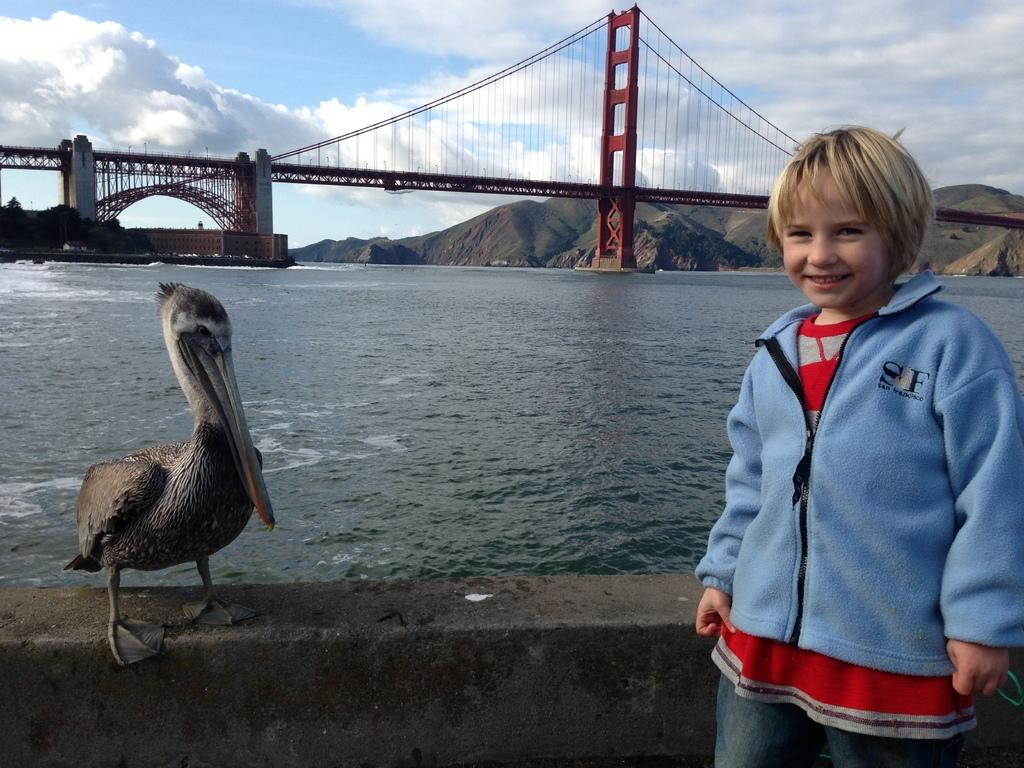What type of structure can be seen in the image? There is a bridge in the image. What is visible beneath the bridge? Water is visible in the image. What type of vegetation is present in the image? There are trees in the image. What is the child in the image doing? The child is standing in the image. Where is the bird located in the image? The bird is on a wall in the image. What can be seen in the background of the image? The sky, clouds, and mountains are visible in the background of the image. What color is the airport in the image? There is no airport present in the image. 